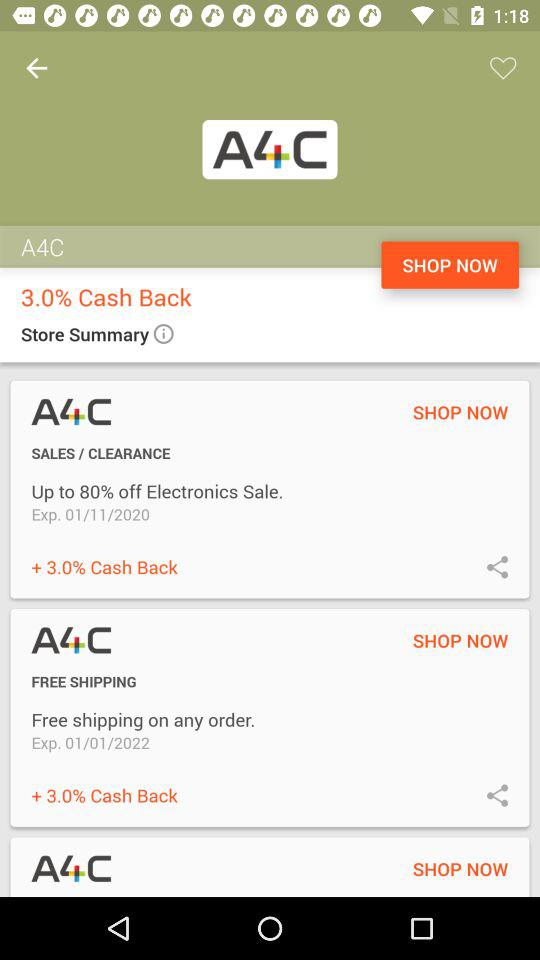Who is this application powered by?
When the provided information is insufficient, respond with <no answer>. <no answer> 